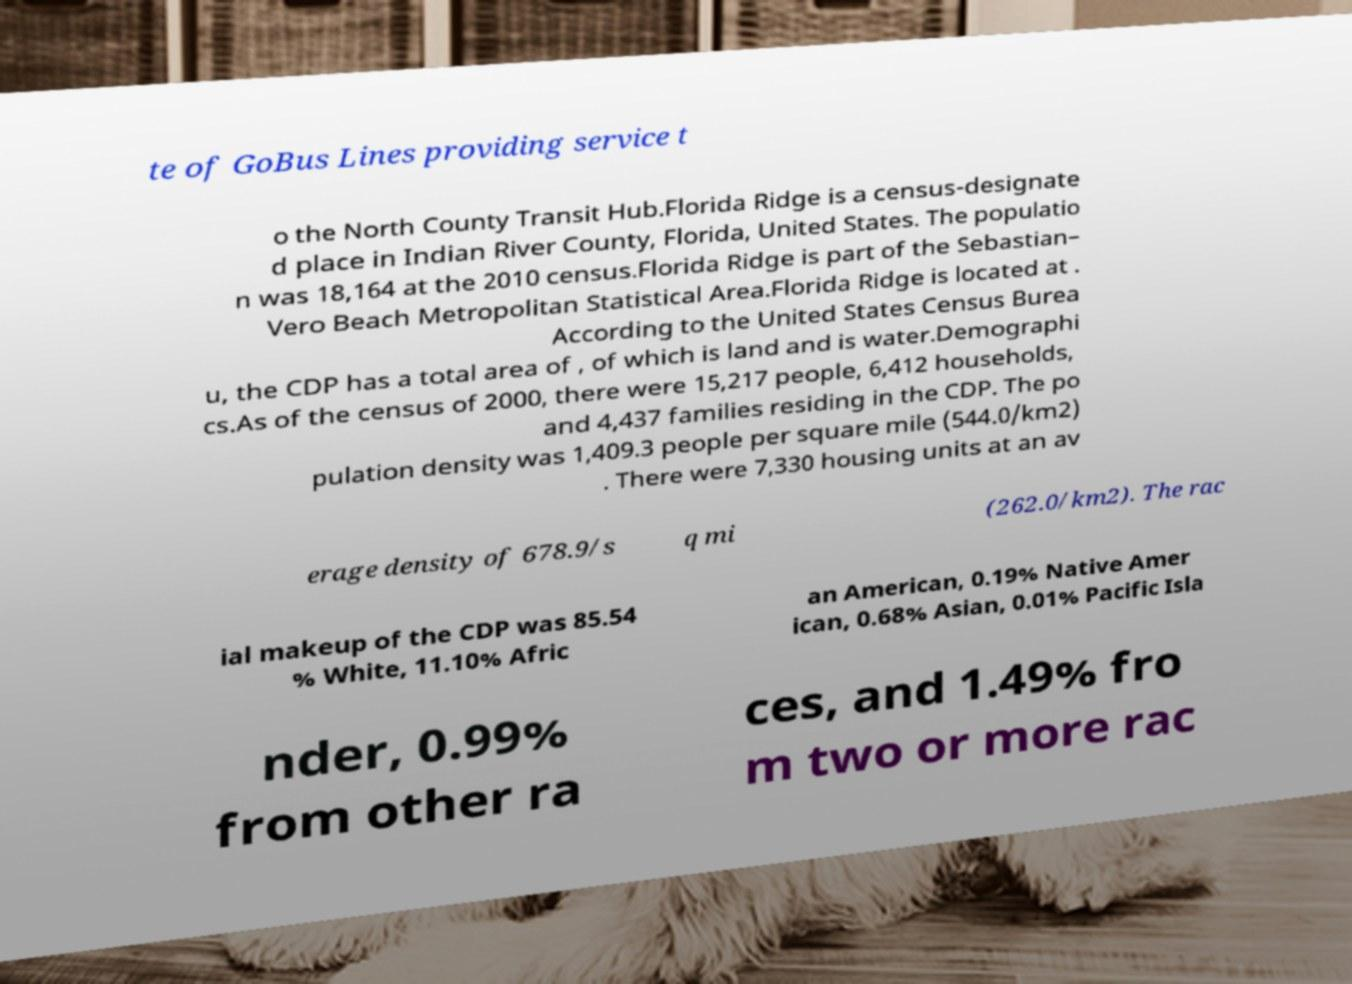What messages or text are displayed in this image? I need them in a readable, typed format. te of GoBus Lines providing service t o the North County Transit Hub.Florida Ridge is a census-designate d place in Indian River County, Florida, United States. The populatio n was 18,164 at the 2010 census.Florida Ridge is part of the Sebastian– Vero Beach Metropolitan Statistical Area.Florida Ridge is located at . According to the United States Census Burea u, the CDP has a total area of , of which is land and is water.Demographi cs.As of the census of 2000, there were 15,217 people, 6,412 households, and 4,437 families residing in the CDP. The po pulation density was 1,409.3 people per square mile (544.0/km2) . There were 7,330 housing units at an av erage density of 678.9/s q mi (262.0/km2). The rac ial makeup of the CDP was 85.54 % White, 11.10% Afric an American, 0.19% Native Amer ican, 0.68% Asian, 0.01% Pacific Isla nder, 0.99% from other ra ces, and 1.49% fro m two or more rac 